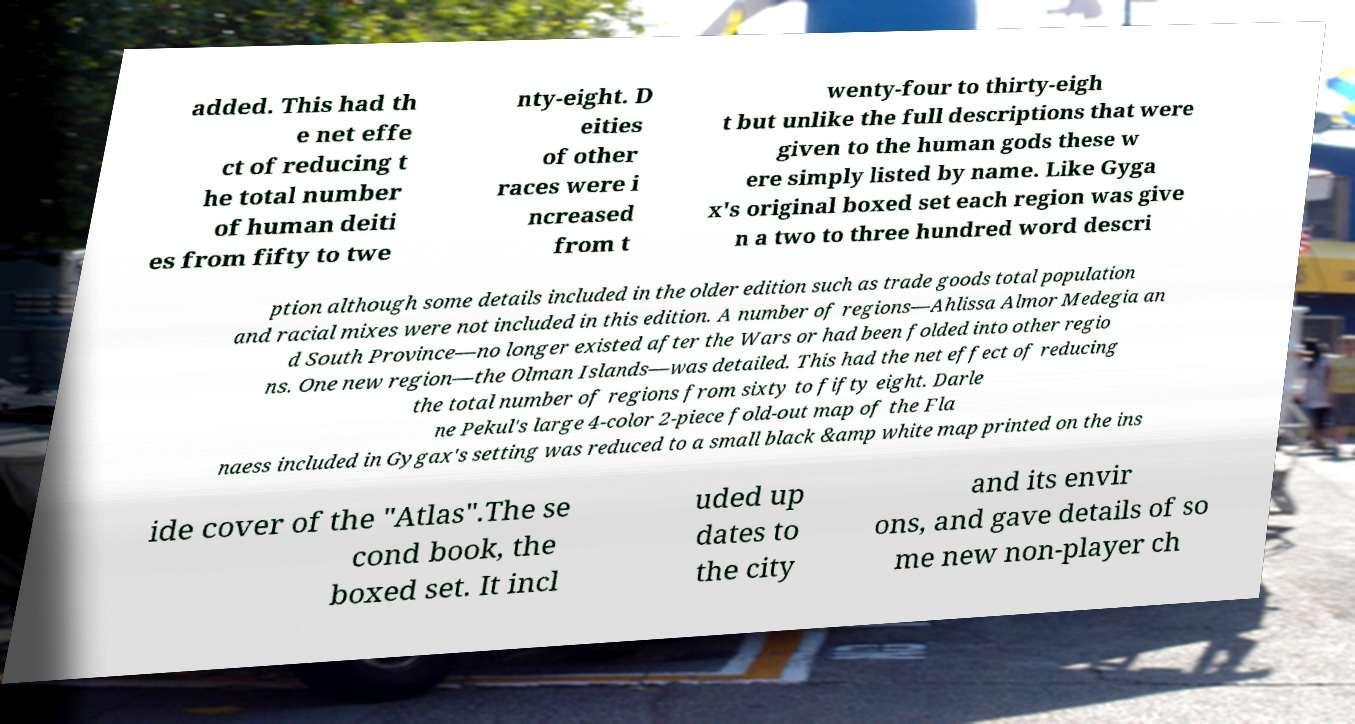What messages or text are displayed in this image? I need them in a readable, typed format. added. This had th e net effe ct of reducing t he total number of human deiti es from fifty to twe nty-eight. D eities of other races were i ncreased from t wenty-four to thirty-eigh t but unlike the full descriptions that were given to the human gods these w ere simply listed by name. Like Gyga x's original boxed set each region was give n a two to three hundred word descri ption although some details included in the older edition such as trade goods total population and racial mixes were not included in this edition. A number of regions—Ahlissa Almor Medegia an d South Province—no longer existed after the Wars or had been folded into other regio ns. One new region—the Olman Islands—was detailed. This had the net effect of reducing the total number of regions from sixty to fifty eight. Darle ne Pekul's large 4-color 2-piece fold-out map of the Fla naess included in Gygax's setting was reduced to a small black &amp white map printed on the ins ide cover of the "Atlas".The se cond book, the boxed set. It incl uded up dates to the city and its envir ons, and gave details of so me new non-player ch 